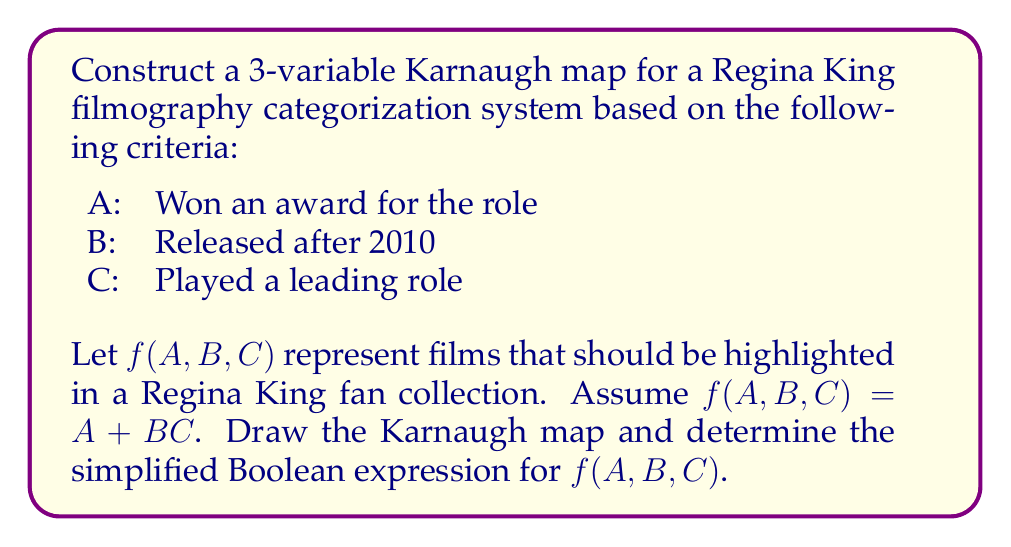Show me your answer to this math problem. To solve this problem, we'll follow these steps:

1. Create the 3-variable Karnaugh map:
   We'll use A, B, and C as our variables, with 8 possible combinations.

2. Fill in the Karnaugh map based on the given function $f(A,B,C) = A + BC$:

   [asy]
   unitsize(1cm);
   
   draw((0,0)--(4,0)--(4,2)--(0,2)--cycle);
   draw((1,0)--(1,2));
   draw((2,0)--(2,2));
   draw((3,0)--(3,2));
   draw((0,1)--(4,1));
   
   label("$\overline{B}\overline{C}$", (0.5,2.3));
   label("$\overline{B}C$", (1.5,2.3));
   label("$BC$", (2.5,2.3));
   label("$B\overline{C}$", (3.5,2.3));
   
   label("$\overline{A}$", (-0.5,1.5));
   label("$A$", (-0.5,0.5));
   
   label("0", (0.5,1.5));
   label("0", (1.5,1.5));
   label("1", (2.5,1.5));
   label("0", (3.5,1.5));
   label("1", (0.5,0.5));
   label("1", (1.5,0.5));
   label("1", (2.5,0.5));
   label("1", (3.5,0.5));
   [/asy]

3. Identify groups of 1's:
   - The entire bottom row (A = 1) forms a group of four 1's
   - The 1 in the top row (BC = 1) is already covered by the group of four

4. Write the simplified Boolean expression:
   The group of four 1's in the bottom row represents A.
   There are no other groups to consider.

Therefore, the simplified Boolean expression is simply A.
Answer: $f(A,B,C) = A$ 